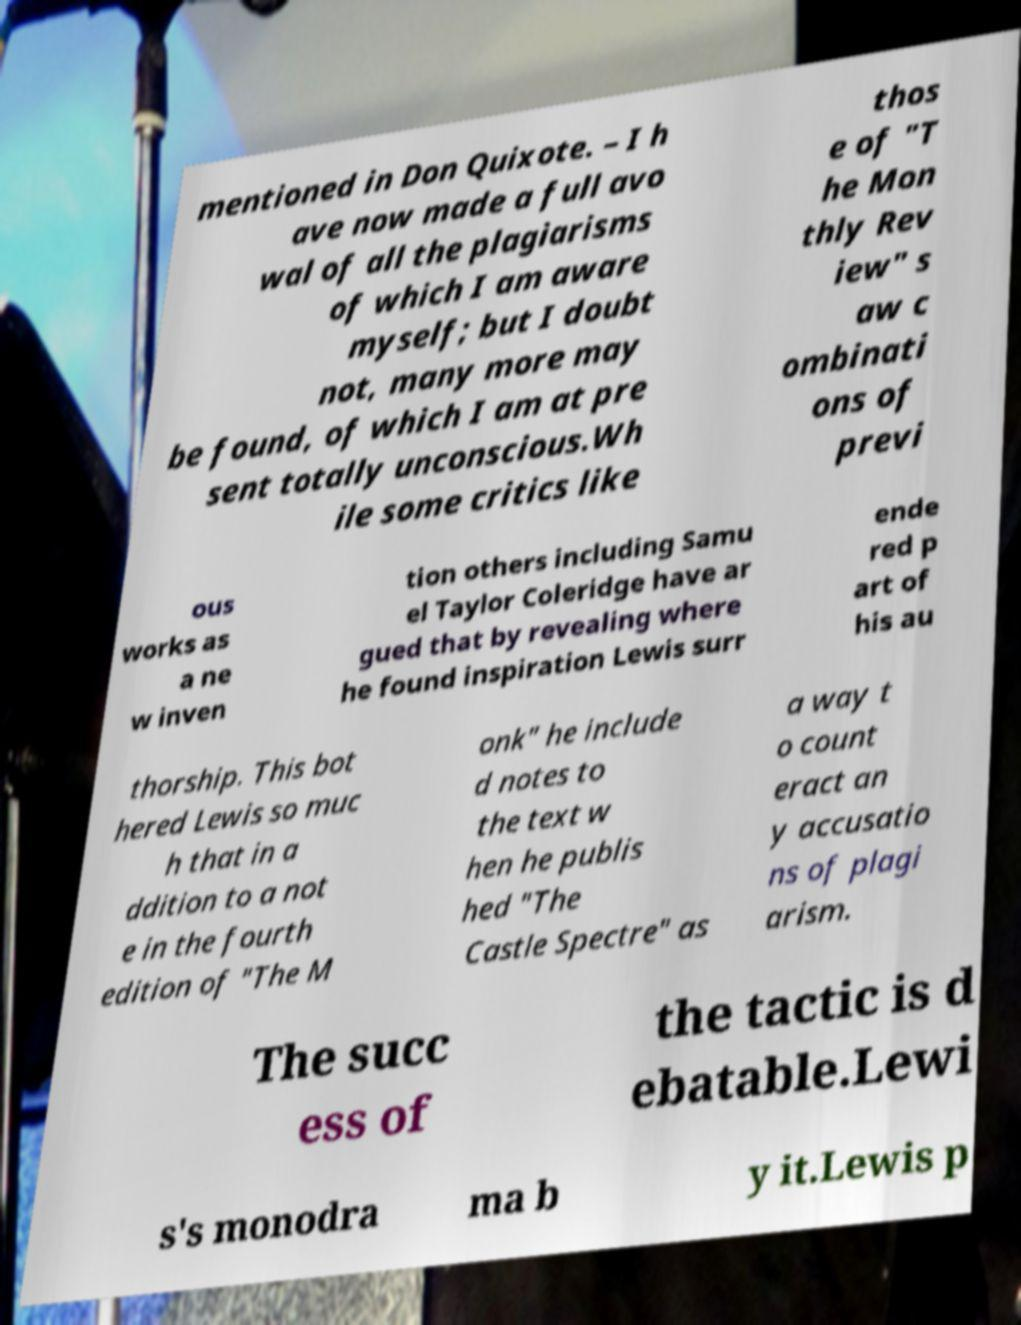Can you accurately transcribe the text from the provided image for me? mentioned in Don Quixote. – I h ave now made a full avo wal of all the plagiarisms of which I am aware myself; but I doubt not, many more may be found, of which I am at pre sent totally unconscious.Wh ile some critics like thos e of "T he Mon thly Rev iew" s aw c ombinati ons of previ ous works as a ne w inven tion others including Samu el Taylor Coleridge have ar gued that by revealing where he found inspiration Lewis surr ende red p art of his au thorship. This bot hered Lewis so muc h that in a ddition to a not e in the fourth edition of "The M onk" he include d notes to the text w hen he publis hed "The Castle Spectre" as a way t o count eract an y accusatio ns of plagi arism. The succ ess of the tactic is d ebatable.Lewi s's monodra ma b y it.Lewis p 